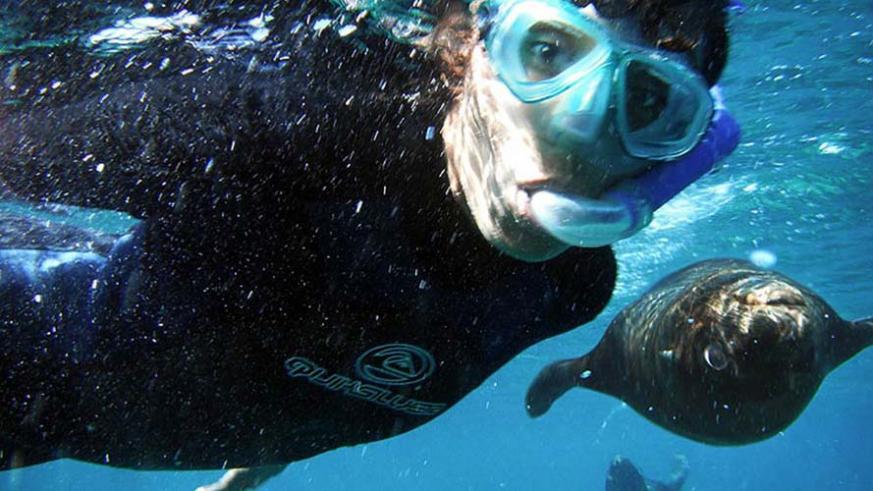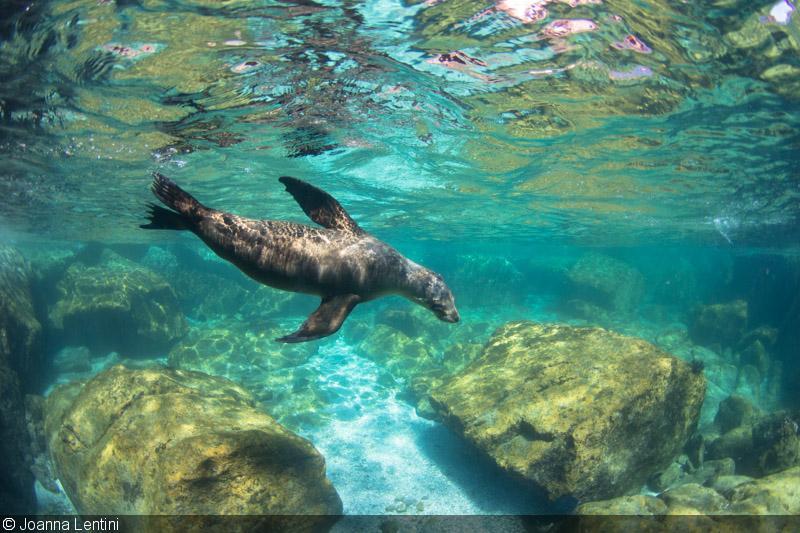The first image is the image on the left, the second image is the image on the right. For the images shown, is this caption "A diver is swimming near a sea animal." true? Answer yes or no. Yes. 